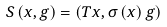<formula> <loc_0><loc_0><loc_500><loc_500>S \left ( x , g \right ) = \left ( T x , \sigma \left ( x \right ) g \right )</formula> 